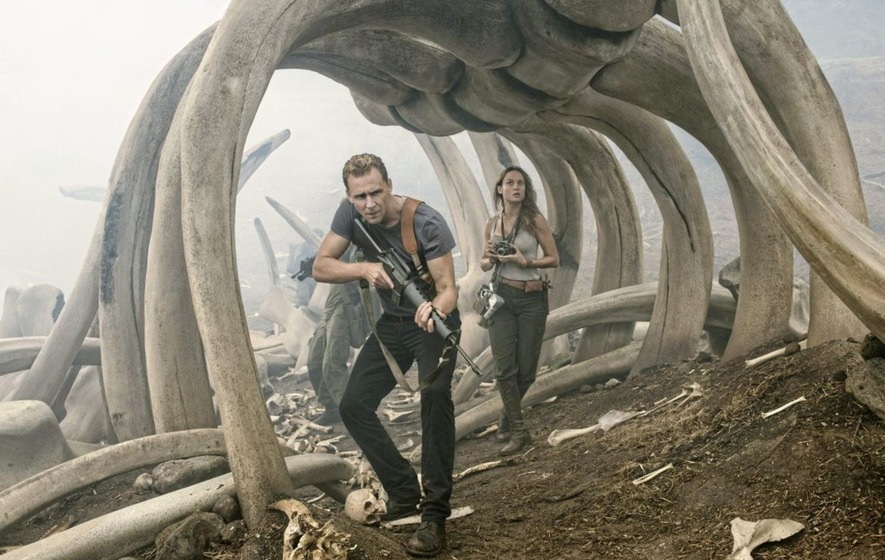Describe a casual interaction between the two characters during a quieter moment. James Conrad exhaled a weary sigh as he leaned against one of the colossal rib bones, wiping sweat from his brow. Mason Weaver, seeing his discomfort, offered him a canteen of water with a reassuring smile. 'It's just another day in paradise, right?' she quipped, trying to lighten the mood. James chuckled, taking a swig of water. 'Yeah, just another day,' he replied, grateful for the brief moment of normalcy amidst their harrowing journey. 